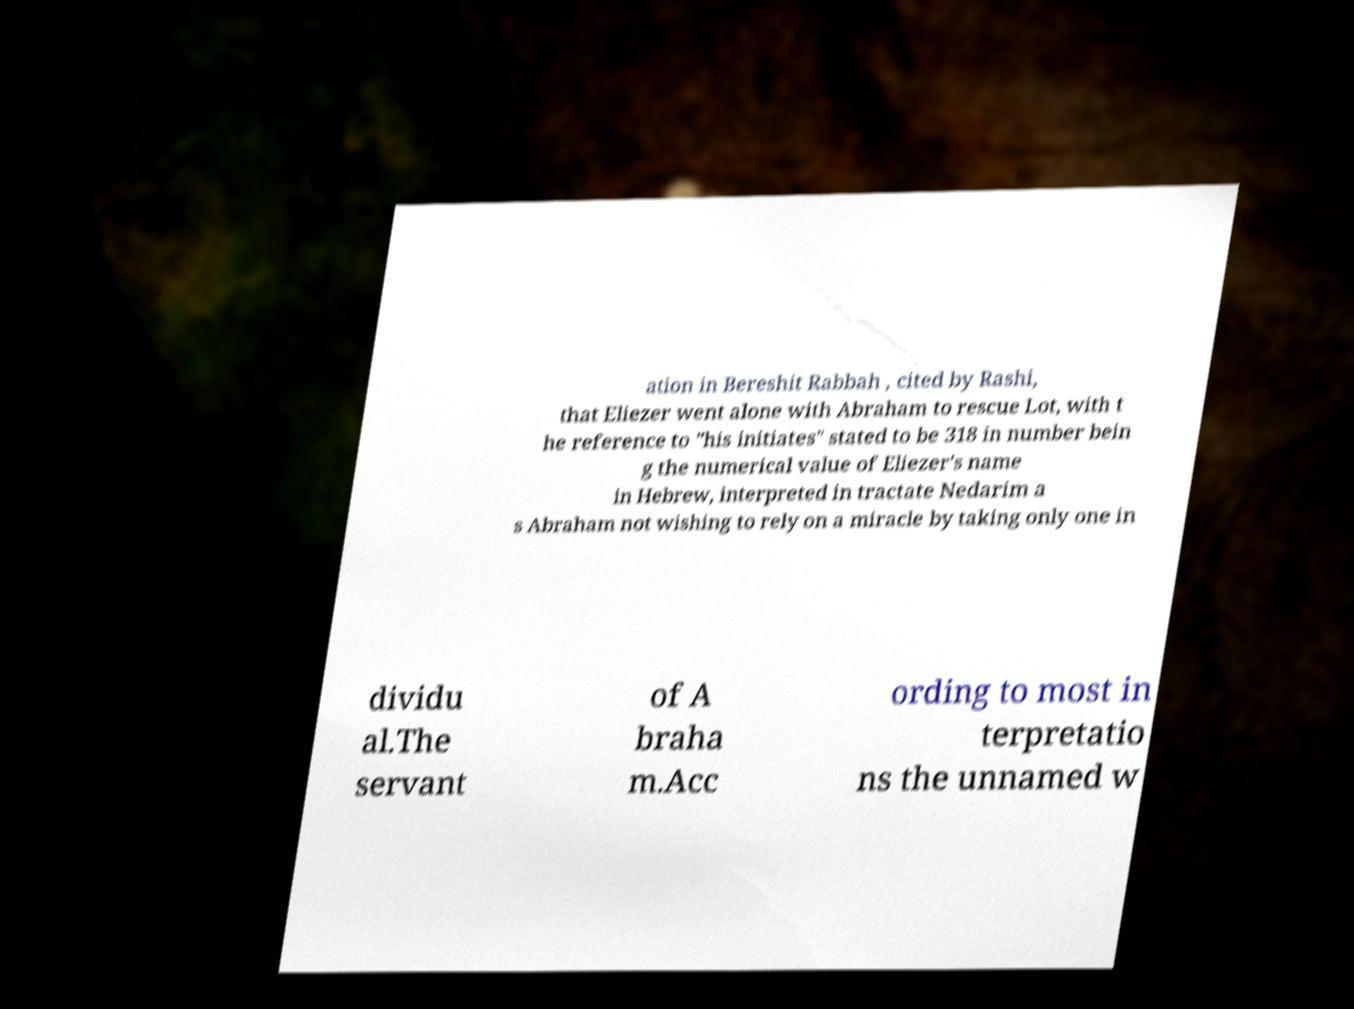Please read and relay the text visible in this image. What does it say? ation in Bereshit Rabbah , cited by Rashi, that Eliezer went alone with Abraham to rescue Lot, with t he reference to "his initiates" stated to be 318 in number bein g the numerical value of Eliezer's name in Hebrew, interpreted in tractate Nedarim a s Abraham not wishing to rely on a miracle by taking only one in dividu al.The servant of A braha m.Acc ording to most in terpretatio ns the unnamed w 